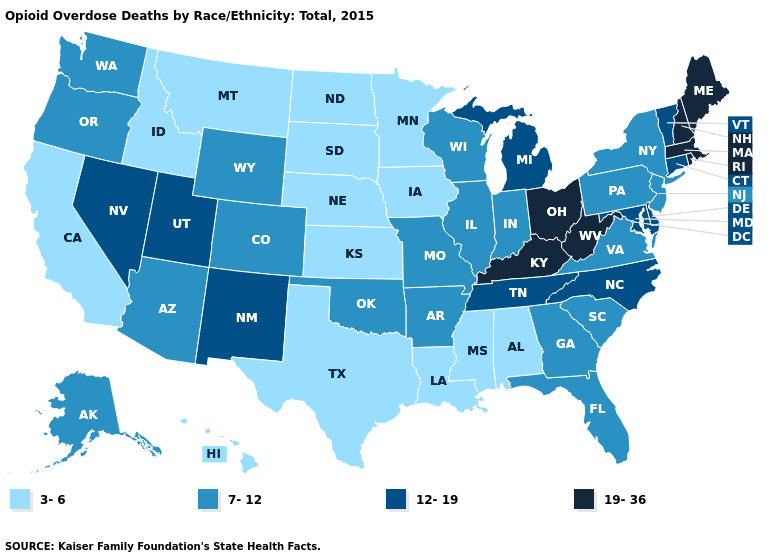Does Mississippi have a lower value than Texas?
Be succinct. No. What is the highest value in the USA?
Be succinct. 19-36. Name the states that have a value in the range 7-12?
Short answer required. Alaska, Arizona, Arkansas, Colorado, Florida, Georgia, Illinois, Indiana, Missouri, New Jersey, New York, Oklahoma, Oregon, Pennsylvania, South Carolina, Virginia, Washington, Wisconsin, Wyoming. How many symbols are there in the legend?
Write a very short answer. 4. Among the states that border Arkansas , which have the highest value?
Concise answer only. Tennessee. What is the highest value in the Northeast ?
Be succinct. 19-36. What is the highest value in the USA?
Quick response, please. 19-36. Does Utah have the lowest value in the West?
Give a very brief answer. No. Which states have the highest value in the USA?
Keep it brief. Kentucky, Maine, Massachusetts, New Hampshire, Ohio, Rhode Island, West Virginia. Among the states that border Missouri , does Kansas have the highest value?
Answer briefly. No. What is the value of Michigan?
Write a very short answer. 12-19. How many symbols are there in the legend?
Short answer required. 4. Which states have the highest value in the USA?
Concise answer only. Kentucky, Maine, Massachusetts, New Hampshire, Ohio, Rhode Island, West Virginia. Does Tennessee have the same value as Rhode Island?
Concise answer only. No. Name the states that have a value in the range 12-19?
Short answer required. Connecticut, Delaware, Maryland, Michigan, Nevada, New Mexico, North Carolina, Tennessee, Utah, Vermont. 